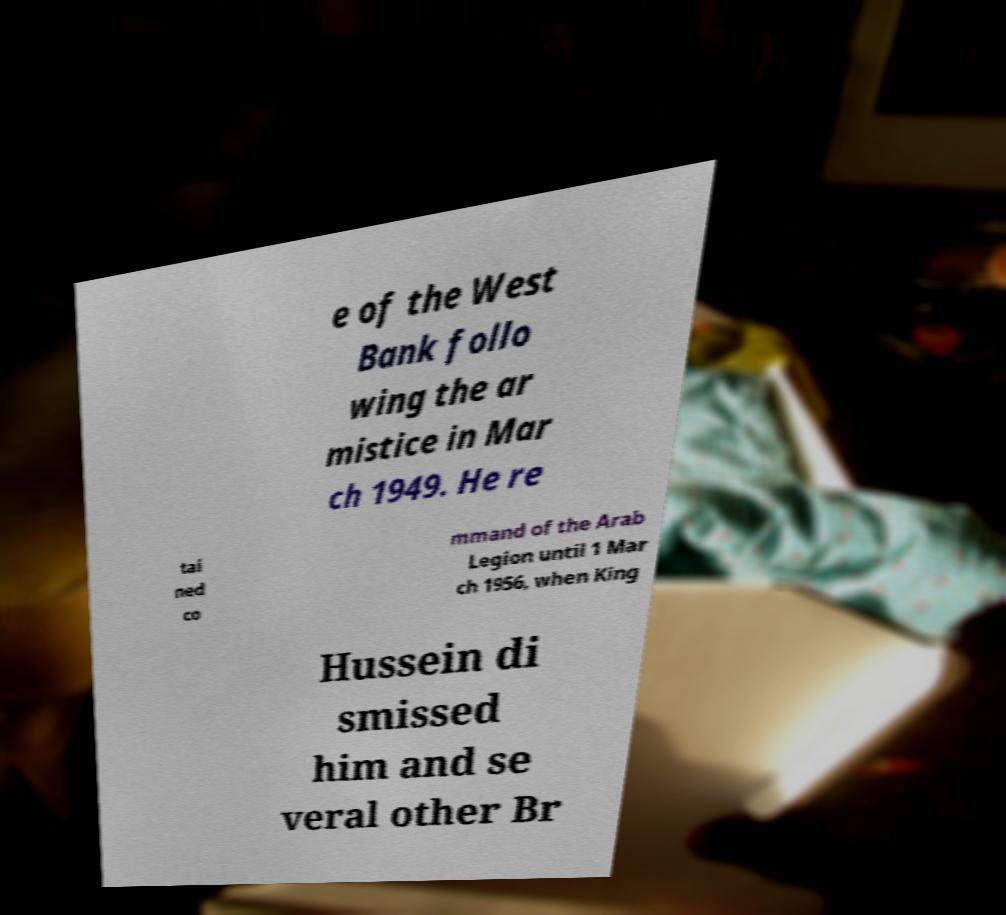Please identify and transcribe the text found in this image. e of the West Bank follo wing the ar mistice in Mar ch 1949. He re tai ned co mmand of the Arab Legion until 1 Mar ch 1956, when King Hussein di smissed him and se veral other Br 